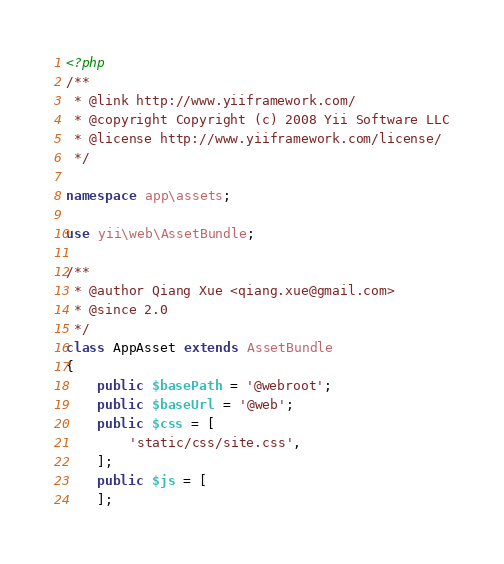Convert code to text. <code><loc_0><loc_0><loc_500><loc_500><_PHP_><?php
/**
 * @link http://www.yiiframework.com/
 * @copyright Copyright (c) 2008 Yii Software LLC
 * @license http://www.yiiframework.com/license/
 */

namespace app\assets;

use yii\web\AssetBundle;

/**
 * @author Qiang Xue <qiang.xue@gmail.com>
 * @since 2.0
 */
class AppAsset extends AssetBundle
{
    public $basePath = '@webroot';
    public $baseUrl = '@web';
    public $css = [
        'static/css/site.css',
    ];
    public $js = [
    ];</code> 